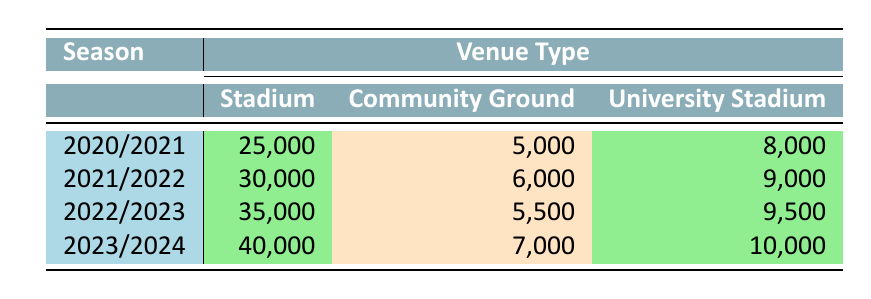What was the highest attendance recorded in the 2022/2023 season? Looking at the 2022/2023 row in the table, the numbers of attendance for each venue type are 35,000 for Stadium, 5,500 for Community Ground, and 9,500 for University Stadium. The highest value among these is 35,000.
Answer: 35,000 Which venue type had the lowest attendance in the 2021/2022 season? In the 2021/2022 season, the attendance figures are 30,000 (Stadium), 6,000 (Community Ground), and 9,000 (University Stadium). The lowest attendance is 6,000 at the Community Ground.
Answer: Community Ground What is the total attendance for the Stadium venue type across all four seasons? Summing the attendance figures for the Stadium over the four seasons, we have 25,000 (2020/2021) + 30,000 (2021/2022) + 35,000 (2022/2023) + 40,000 (2023/2024) = 130,000.
Answer: 130,000 Is it true that the community ground attendance increased every season? We check the data for Community Ground attendance across seasons: 5,000 (2020/2021), 6,000 (2021/2022), 5,500 (2022/2023), and 7,000 (2023/2024). The attendance decreased from 2021/2022 to 2022/2023, so it is not true.
Answer: No What was the average attendance for the University Stadium over all the seasons? The attendance for University Stadium is 8,000 (2020/2021), 9,000 (2021/2022), 9,500 (2022/2023), and 10,000 (2023/2024). Adding these gives 8,000 + 9,000 + 9,500 + 10,000 = 36,500. Dividing by 4 gives an average of 36,500 / 4 = 9,125.
Answer: 9,125 Which season saw the most significant increase in attendance at the Stadium venue? Examining the Stadium attendance figures: 25,000 (2020/2021), 30,000 (2021/2022), 35,000 (2022/2023), and 40,000 (2023/2024). The increases are 5,000 from 2020/2021 to 2021/2022, 5,000 from 2021/2022 to 2022/2023, and 5,000 from 2022/2023 to 2023/2024. All increases are equal, so the greatest is 5,000.
Answer: 5,000 Did the attendance at the Community Ground decrease from 2021/2022 to 2022/2023? The attendance figures for Community Ground are 6,000 (2021/2022) and 5,500 (2022/2023). Since 5,500 is less than 6,000, it indicates a decrease.
Answer: Yes 